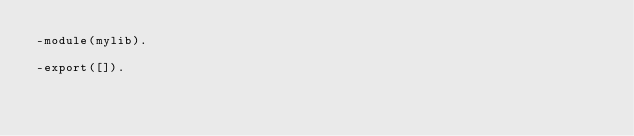<code> <loc_0><loc_0><loc_500><loc_500><_Erlang_>-module(mylib).

-export([]).
</code> 